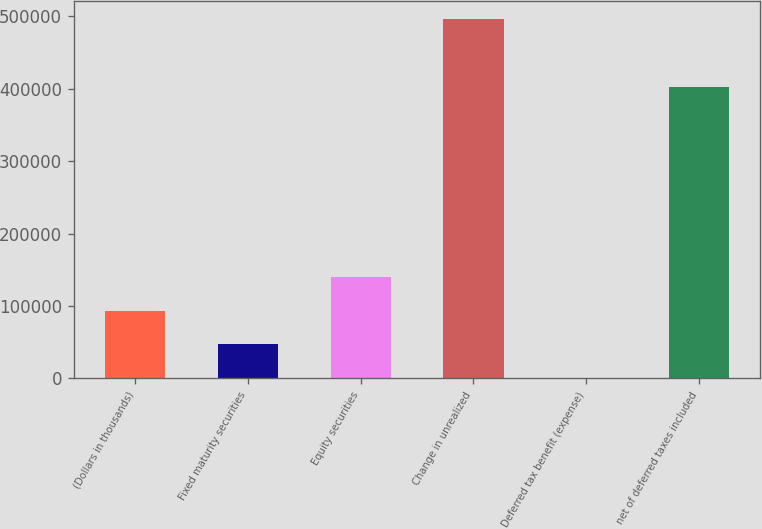Convert chart to OTSL. <chart><loc_0><loc_0><loc_500><loc_500><bar_chart><fcel>(Dollars in thousands)<fcel>Fixed maturity securities<fcel>Equity securities<fcel>Change in unrealized<fcel>Deferred tax benefit (expense)<fcel>net of deferred taxes included<nl><fcel>93543.8<fcel>46841.9<fcel>140246<fcel>496178<fcel>140<fcel>402774<nl></chart> 